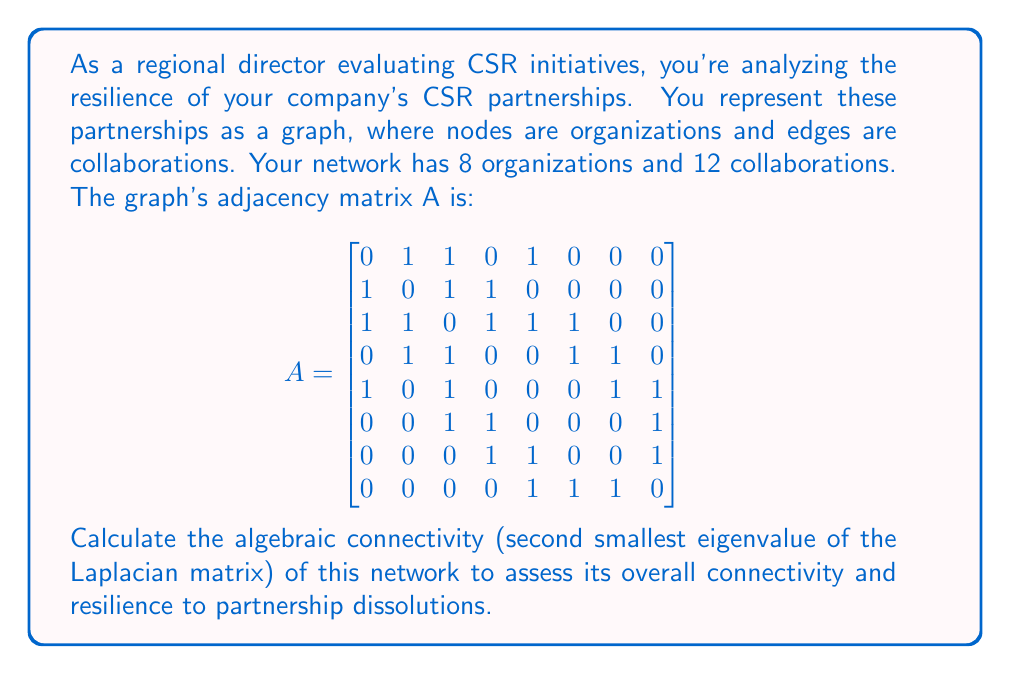Help me with this question. To solve this problem, we'll follow these steps:

1) First, we need to calculate the Laplacian matrix L of the graph. The Laplacian matrix is defined as L = D - A, where D is the degree matrix and A is the adjacency matrix.

2) The degree matrix D is a diagonal matrix where each entry $d_{ii}$ is the degree of vertex i. We can calculate this by summing each row of the adjacency matrix:

$$D = \begin{bmatrix}
3 & 0 & 0 & 0 & 0 & 0 & 0 & 0 \\
0 & 3 & 0 & 0 & 0 & 0 & 0 & 0 \\
0 & 0 & 5 & 0 & 0 & 0 & 0 & 0 \\
0 & 0 & 0 & 4 & 0 & 0 & 0 & 0 \\
0 & 0 & 0 & 0 & 4 & 0 & 0 & 0 \\
0 & 0 & 0 & 0 & 0 & 3 & 0 & 0 \\
0 & 0 & 0 & 0 & 0 & 0 & 3 & 0 \\
0 & 0 & 0 & 0 & 0 & 0 & 0 & 3
\end{bmatrix}$$

3) Now we can calculate the Laplacian matrix L = D - A:

$$L = \begin{bmatrix}
3 & -1 & -1 & 0 & -1 & 0 & 0 & 0 \\
-1 & 3 & -1 & -1 & 0 & 0 & 0 & 0 \\
-1 & -1 & 5 & -1 & -1 & -1 & 0 & 0 \\
0 & -1 & -1 & 4 & 0 & -1 & -1 & 0 \\
-1 & 0 & -1 & 0 & 4 & 0 & -1 & -1 \\
0 & 0 & -1 & -1 & 0 & 3 & 0 & -1 \\
0 & 0 & 0 & -1 & -1 & 0 & 3 & -1 \\
0 & 0 & 0 & 0 & -1 & -1 & -1 & 3
\end{bmatrix}$$

4) The algebraic connectivity is the second smallest eigenvalue of L. To find this, we need to calculate the eigenvalues of L.

5) Using a computer algebra system or numerical methods, we can calculate the eigenvalues of L. They are approximately:

   0, 0.7639, 1.9098, 2.7639, 3.6889, 4.2361, 5.0000, 5.6374

6) The second smallest eigenvalue (the algebraic connectivity) is approximately 0.7639.

The algebraic connectivity is a measure of how well-connected the graph is as a whole. A higher value indicates a more connected and resilient network. In this case, the value of 0.7639 suggests a moderately connected network that has some resilience to partnership dissolutions, but there's room for improvement in strengthening connections.
Answer: The algebraic connectivity of the CSR partnership network is approximately 0.7639. 